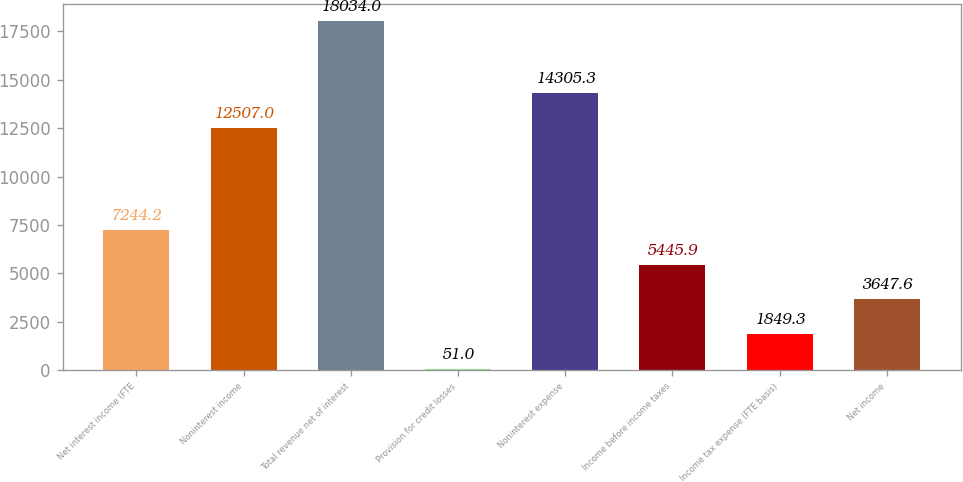<chart> <loc_0><loc_0><loc_500><loc_500><bar_chart><fcel>Net interest income (FTE<fcel>Noninterest income<fcel>Total revenue net of interest<fcel>Provision for credit losses<fcel>Noninterest expense<fcel>Income before income taxes<fcel>Income tax expense (FTE basis)<fcel>Net income<nl><fcel>7244.2<fcel>12507<fcel>18034<fcel>51<fcel>14305.3<fcel>5445.9<fcel>1849.3<fcel>3647.6<nl></chart> 